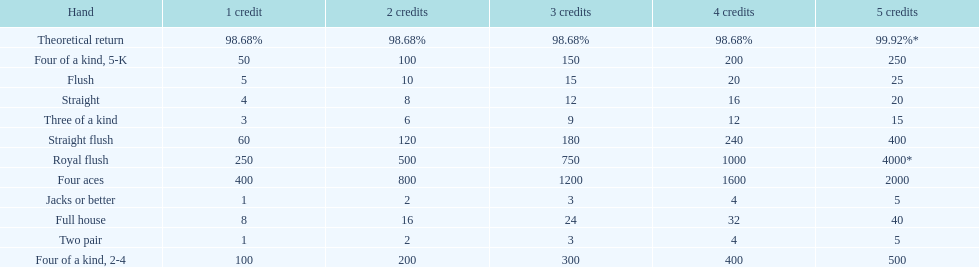Is four 5s worth more or less than four 2s? Less. Write the full table. {'header': ['Hand', '1 credit', '2 credits', '3 credits', '4 credits', '5 credits'], 'rows': [['Theoretical return', '98.68%', '98.68%', '98.68%', '98.68%', '99.92%*'], ['Four of a kind, 5-K', '50', '100', '150', '200', '250'], ['Flush', '5', '10', '15', '20', '25'], ['Straight', '4', '8', '12', '16', '20'], ['Three of a kind', '3', '6', '9', '12', '15'], ['Straight flush', '60', '120', '180', '240', '400'], ['Royal flush', '250', '500', '750', '1000', '4000*'], ['Four aces', '400', '800', '1200', '1600', '2000'], ['Jacks or better', '1', '2', '3', '4', '5'], ['Full house', '8', '16', '24', '32', '40'], ['Two pair', '1', '2', '3', '4', '5'], ['Four of a kind, 2-4', '100', '200', '300', '400', '500']]} 